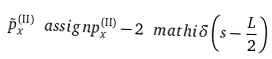<formula> <loc_0><loc_0><loc_500><loc_500>\tilde { p } ^ { \left ( \text {II} \right ) } _ { x } \ a s s i g n p ^ { \left ( \text {II} \right ) } _ { x } - 2 \ m a t h i \delta \left ( s - \frac { L } { 2 } \right )</formula> 